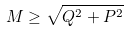<formula> <loc_0><loc_0><loc_500><loc_500>M \geq \sqrt { Q ^ { 2 } + P ^ { 2 } }</formula> 